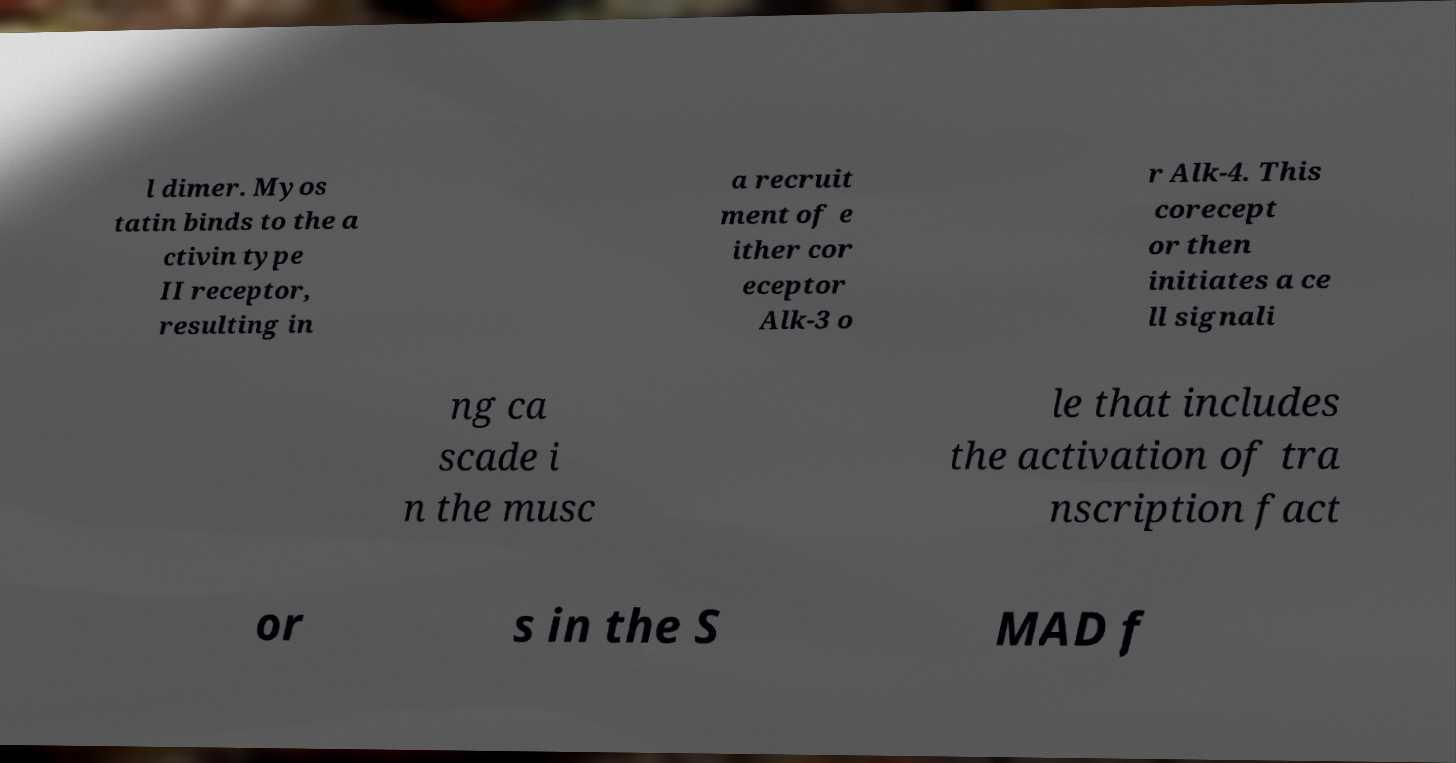Could you extract and type out the text from this image? l dimer. Myos tatin binds to the a ctivin type II receptor, resulting in a recruit ment of e ither cor eceptor Alk-3 o r Alk-4. This corecept or then initiates a ce ll signali ng ca scade i n the musc le that includes the activation of tra nscription fact or s in the S MAD f 